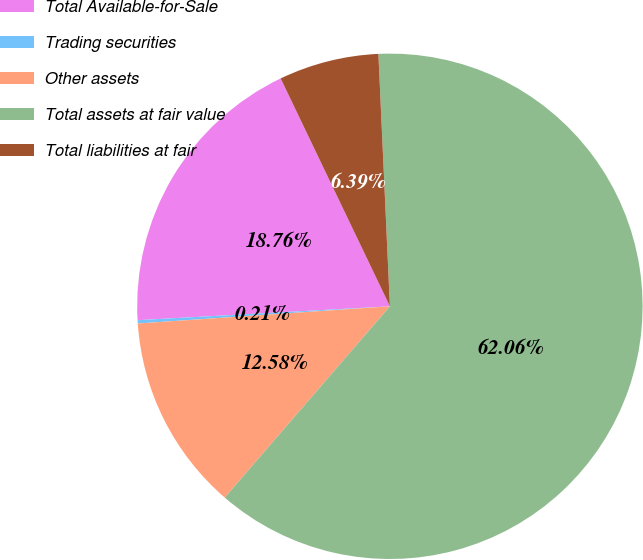Convert chart. <chart><loc_0><loc_0><loc_500><loc_500><pie_chart><fcel>Total Available-for-Sale<fcel>Trading securities<fcel>Other assets<fcel>Total assets at fair value<fcel>Total liabilities at fair<nl><fcel>18.76%<fcel>0.21%<fcel>12.58%<fcel>62.06%<fcel>6.39%<nl></chart> 